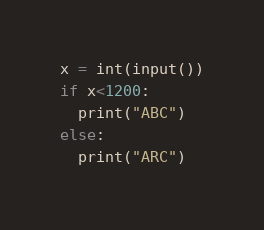Convert code to text. <code><loc_0><loc_0><loc_500><loc_500><_Python_>x = int(input())
if x<1200:
  print("ABC")
else:
  print("ARC")</code> 